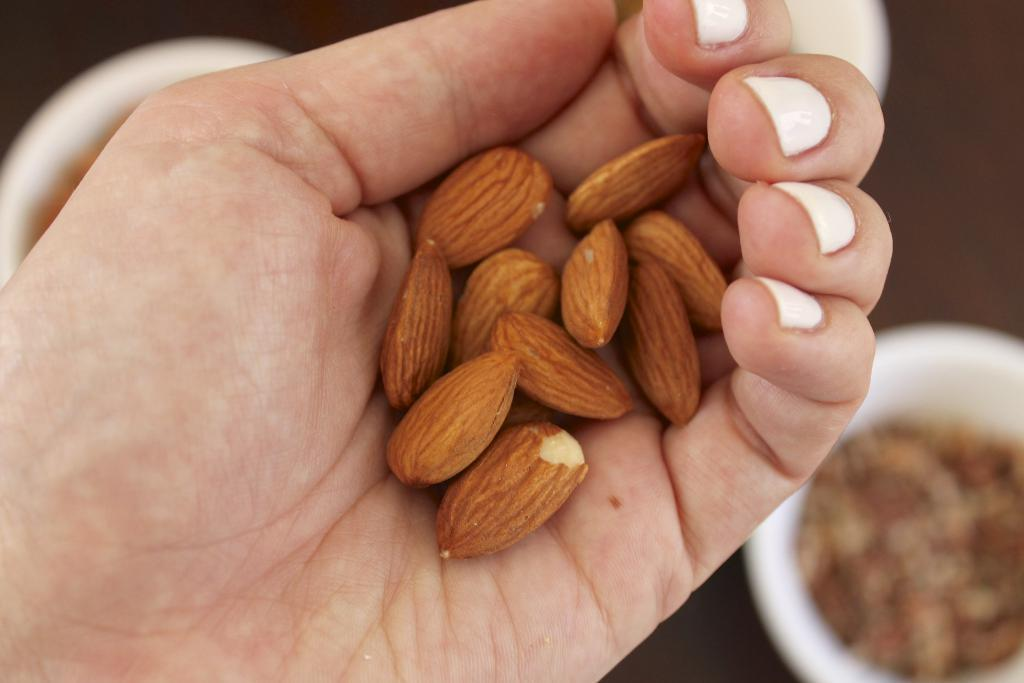What is being held by the hand in the image? The hand is holding a bunch of nuts. What is the hand doing with the nuts? The hand is holding the nuts, but the image does not show any action being taken with them. What can be seen on the table in the image? There are bowls on a table in the image. What is inside the bowls on the table? The bowls contain food. What type of flowers are arranged in the pan on the table? There are no flowers or pans present in the image; it only shows a hand holding nuts and bowls containing food on a table. 